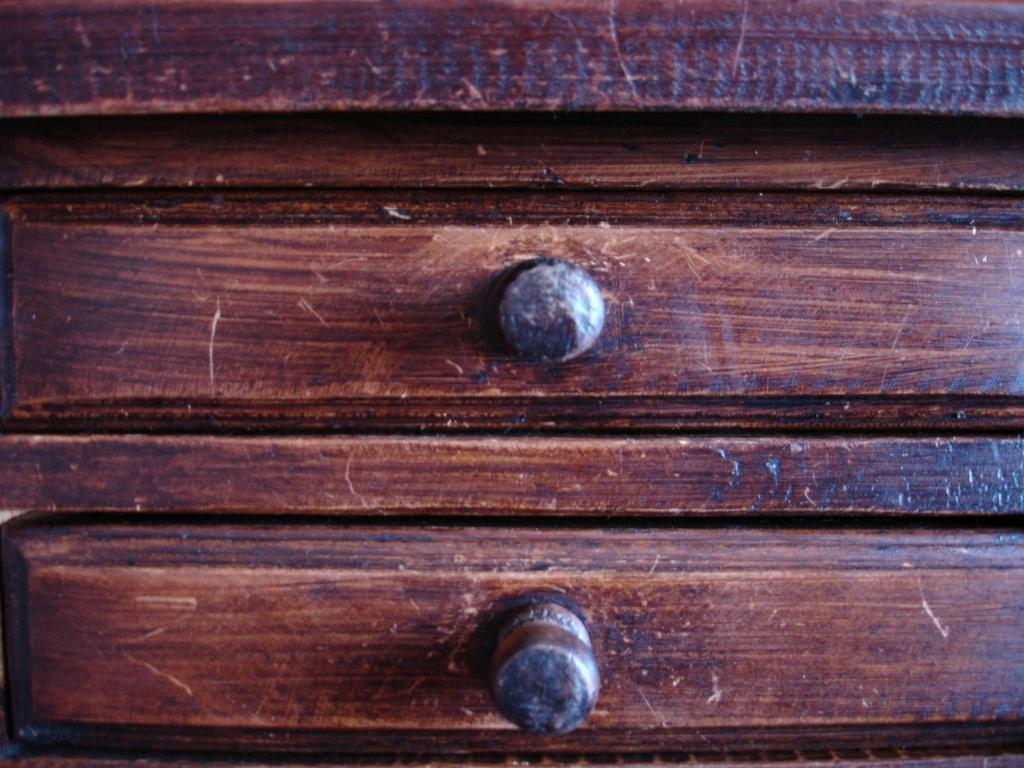What type of material is present in the image? The image contains brown-colored wood. Are there any specific features visible on the wood? Yes, there are bolts visible on the wood. What type of stove can be seen in the image? There is no stove present in the image; it only contains brown-colored wood with visible bolts. 